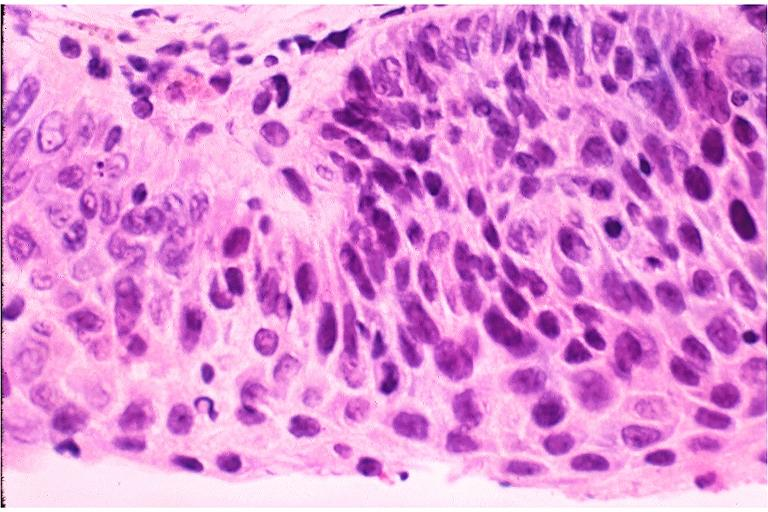does this image show severe epithelial dysplasia?
Answer the question using a single word or phrase. Yes 